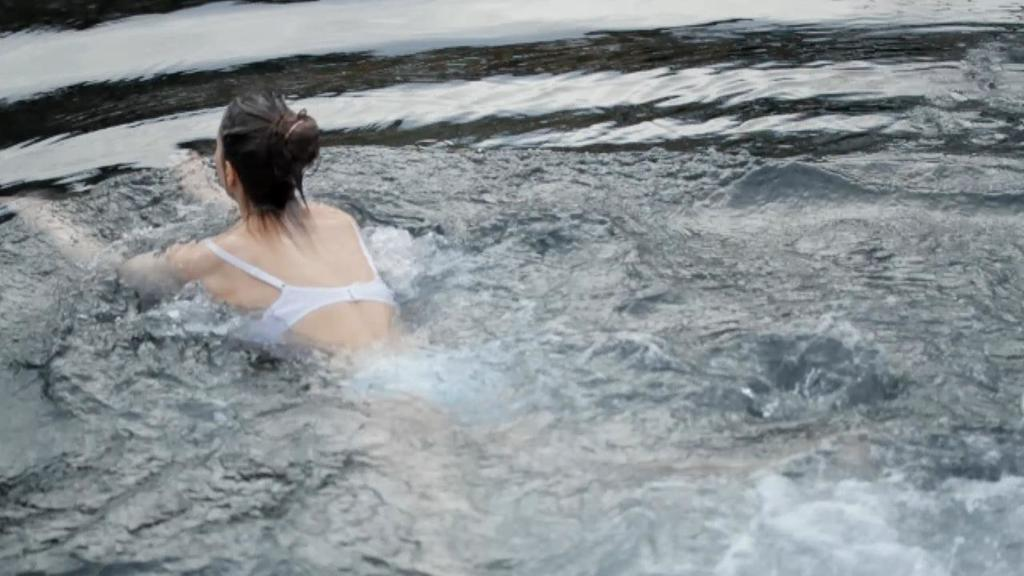Who is present in the image? There is a lady in the image. What is the lady doing in the image? The lady is in water. What type of curtain is hanging near the lady in the image? There is no curtain present in the image; the lady is in water. What color is the lady's dress in the image? There is no information about the lady's dress in the provided facts, so we cannot determine its color. 